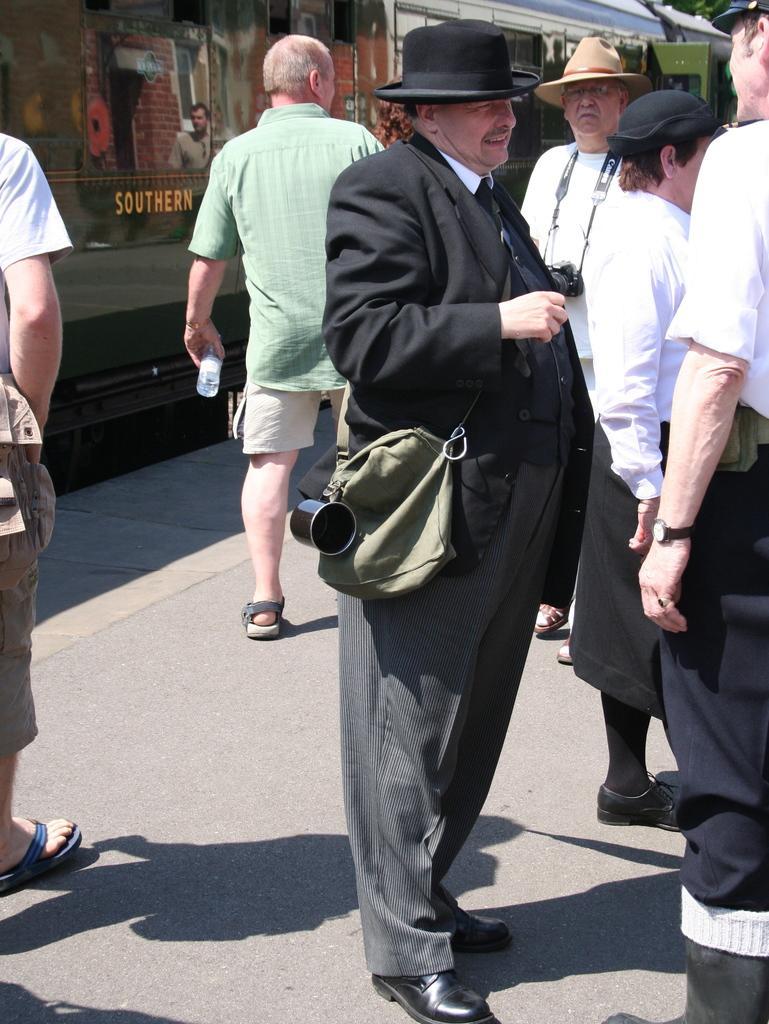How would you summarize this image in a sentence or two? This image is clicked on the road. There are a few men standing on the road. In the center there is a man standing on the road. He is wearing a hat and a bag. Behind them there are houses. There are pictures and text on the walls. 